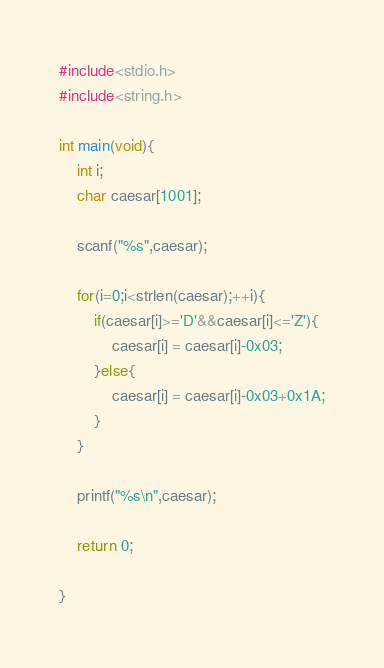Convert code to text. <code><loc_0><loc_0><loc_500><loc_500><_C_>#include<stdio.h>
#include<string.h>

int main(void){
	int i;
	char caesar[1001];
	
	scanf("%s",caesar);
	
	for(i=0;i<strlen(caesar);++i){
		if(caesar[i]>='D'&&caesar[i]<='Z'){
			caesar[i] = caesar[i]-0x03;
		}else{
			caesar[i] = caesar[i]-0x03+0x1A;
		}
	}
	
	printf("%s\n",caesar);

	return 0;
	
}</code> 